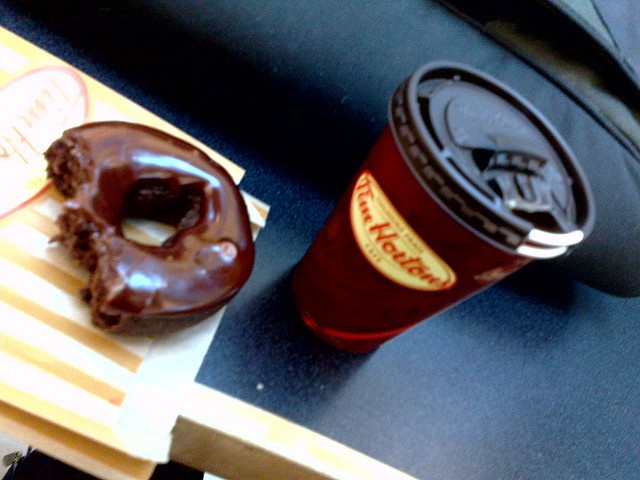Describe the objects in this image and their specific colors. I can see cup in black, maroon, and gray tones and donut in black, maroon, gray, and brown tones in this image. 